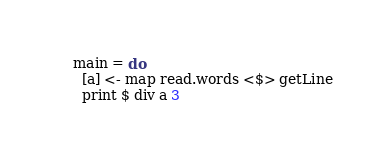<code> <loc_0><loc_0><loc_500><loc_500><_Haskell_>    main = do
      [a] <- map read.words <$> getLine
      print $ div a 3</code> 